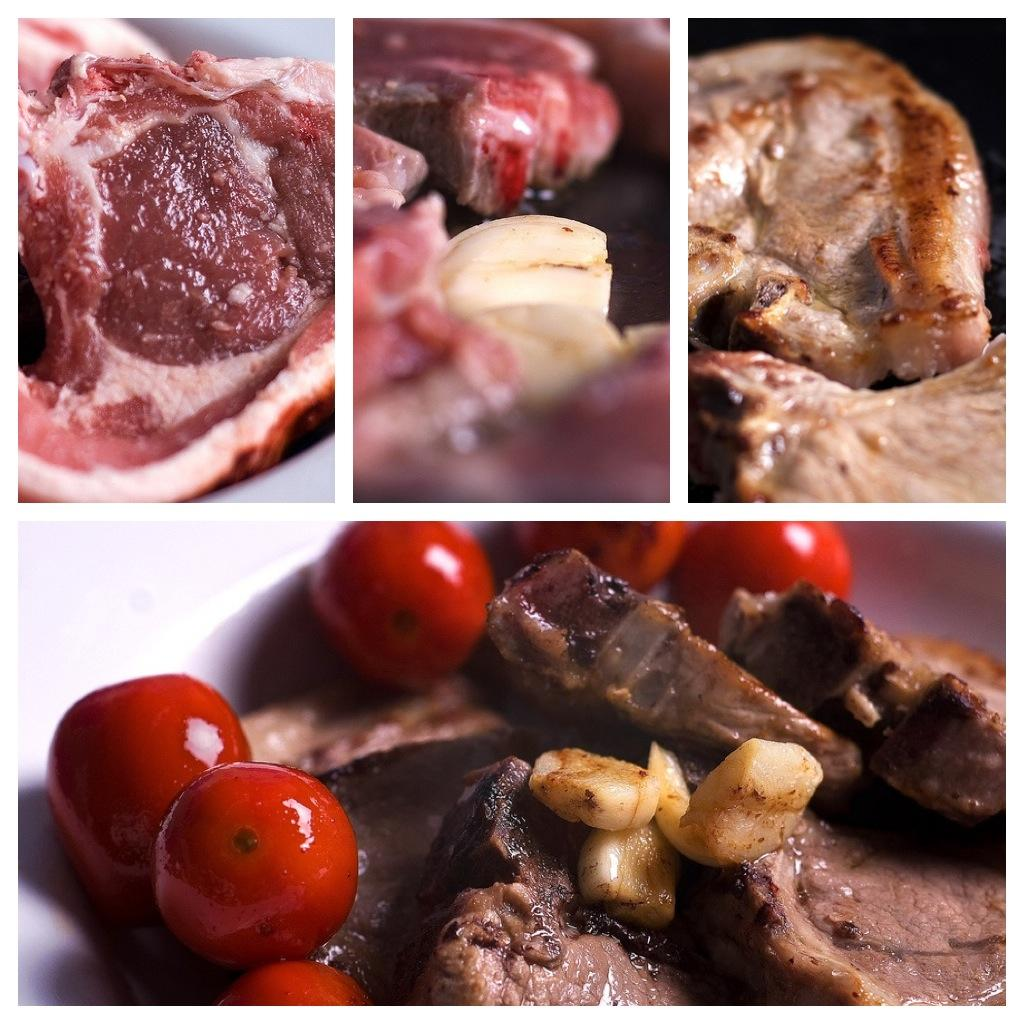What type of collage is depicted in the image? The image is a collage of different food items. What is the primary ingredient of the food items in the collage? The food items are made up of meat. What insect can be seen crawling on the meat in the image? There are no insects present in the image; it is a collage of different food items made up of meat. 